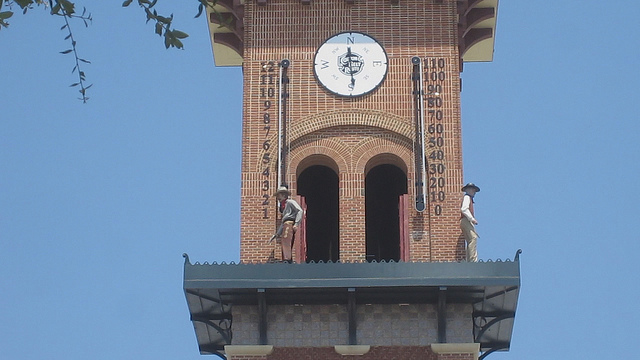Can you describe the architectural style of the tower where the clock is mounted? The tower exhibits features characteristic of traditional brick architecture, with its red brick facade and distinct geometric patterns. The triangular pediments and arched openings topped with semi-circular shapes, along with the corbelling at the top of the tower under the roof, suggest influences from historical styles possibly inspired by European architecture. Its tall and slender form helps in making the clock visible from a distance. 